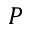Convert formula to latex. <formula><loc_0><loc_0><loc_500><loc_500>P</formula> 